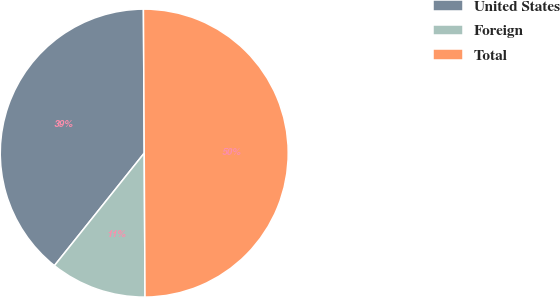Convert chart to OTSL. <chart><loc_0><loc_0><loc_500><loc_500><pie_chart><fcel>United States<fcel>Foreign<fcel>Total<nl><fcel>39.19%<fcel>10.81%<fcel>50.0%<nl></chart> 